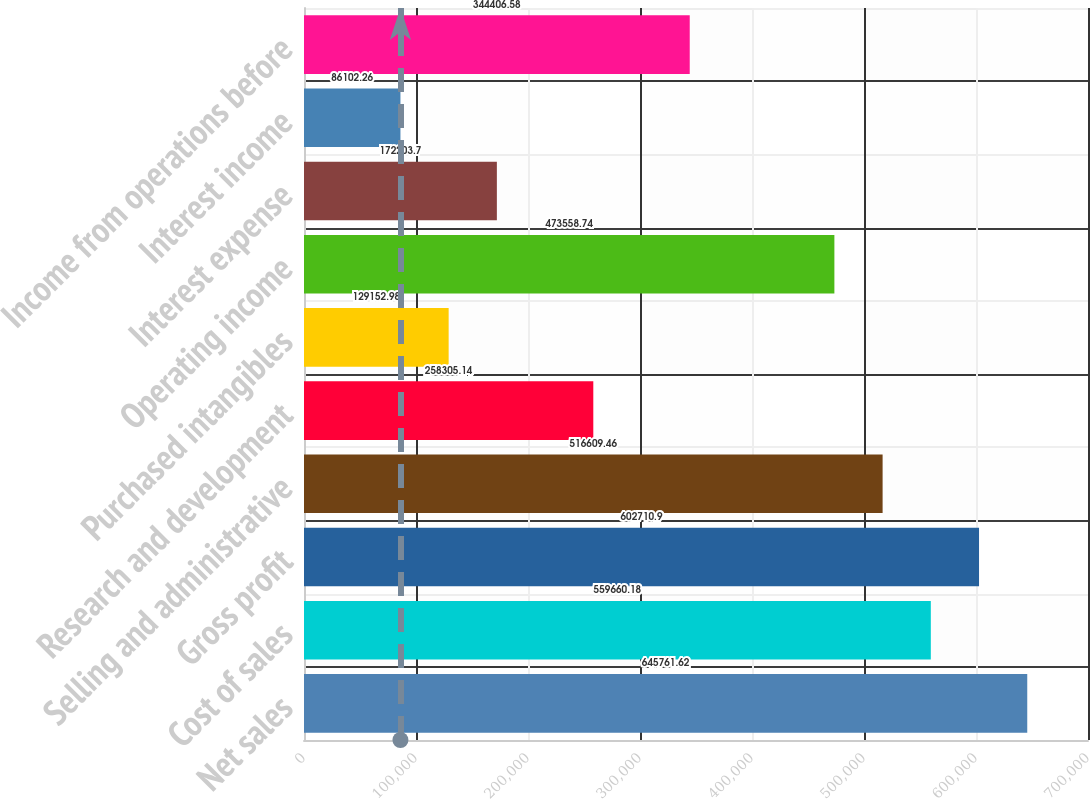<chart> <loc_0><loc_0><loc_500><loc_500><bar_chart><fcel>Net sales<fcel>Cost of sales<fcel>Gross profit<fcel>Selling and administrative<fcel>Research and development<fcel>Purchased intangibles<fcel>Operating income<fcel>Interest expense<fcel>Interest income<fcel>Income from operations before<nl><fcel>645762<fcel>559660<fcel>602711<fcel>516609<fcel>258305<fcel>129153<fcel>473559<fcel>172204<fcel>86102.3<fcel>344407<nl></chart> 